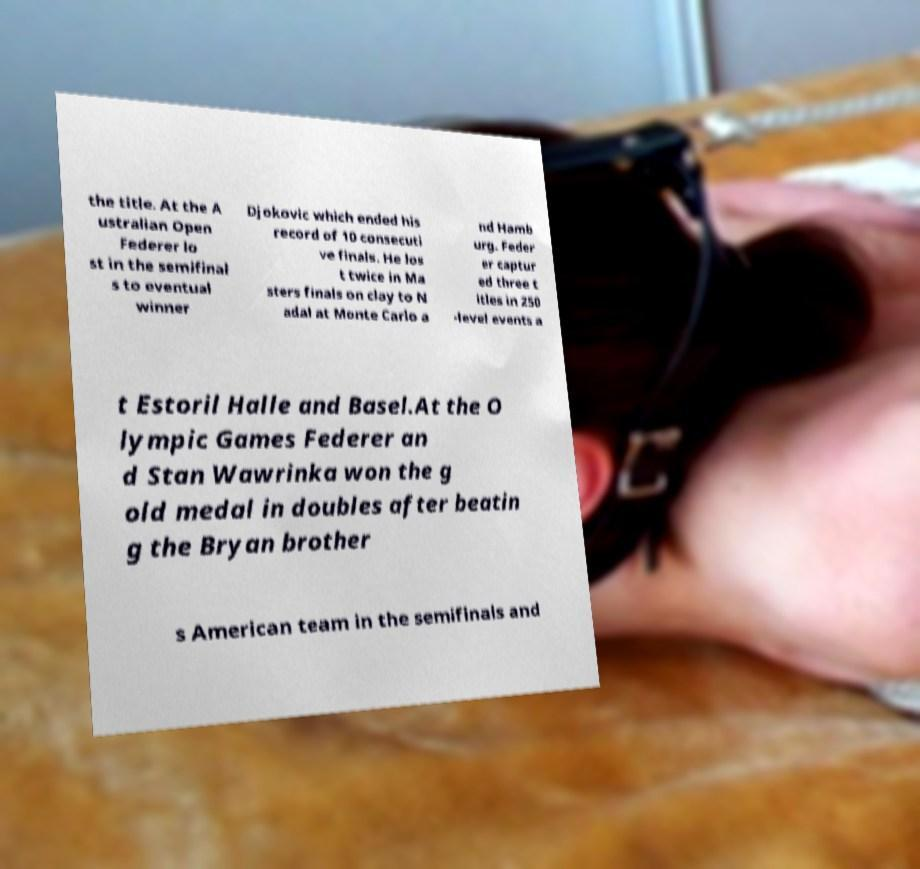For documentation purposes, I need the text within this image transcribed. Could you provide that? the title. At the A ustralian Open Federer lo st in the semifinal s to eventual winner Djokovic which ended his record of 10 consecuti ve finals. He los t twice in Ma sters finals on clay to N adal at Monte Carlo a nd Hamb urg. Feder er captur ed three t itles in 250 -level events a t Estoril Halle and Basel.At the O lympic Games Federer an d Stan Wawrinka won the g old medal in doubles after beatin g the Bryan brother s American team in the semifinals and 